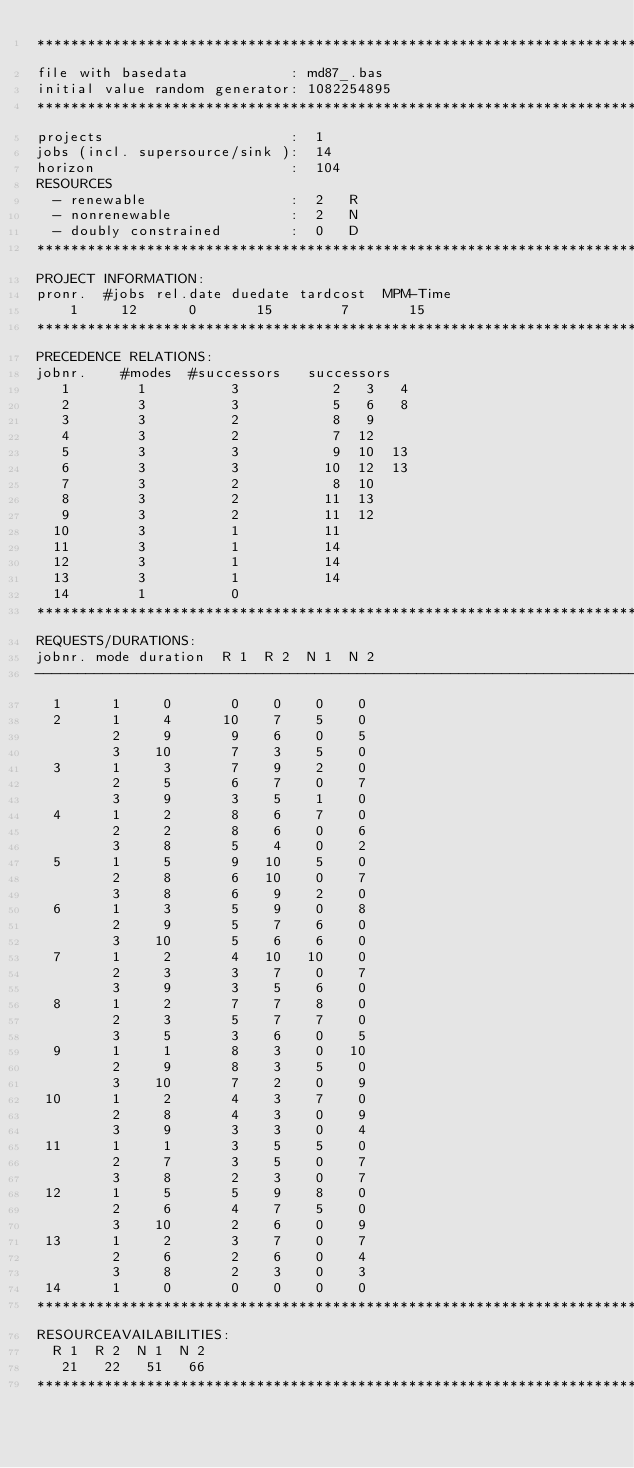Convert code to text. <code><loc_0><loc_0><loc_500><loc_500><_ObjectiveC_>************************************************************************
file with basedata            : md87_.bas
initial value random generator: 1082254895
************************************************************************
projects                      :  1
jobs (incl. supersource/sink ):  14
horizon                       :  104
RESOURCES
  - renewable                 :  2   R
  - nonrenewable              :  2   N
  - doubly constrained        :  0   D
************************************************************************
PROJECT INFORMATION:
pronr.  #jobs rel.date duedate tardcost  MPM-Time
    1     12      0       15        7       15
************************************************************************
PRECEDENCE RELATIONS:
jobnr.    #modes  #successors   successors
   1        1          3           2   3   4
   2        3          3           5   6   8
   3        3          2           8   9
   4        3          2           7  12
   5        3          3           9  10  13
   6        3          3          10  12  13
   7        3          2           8  10
   8        3          2          11  13
   9        3          2          11  12
  10        3          1          11
  11        3          1          14
  12        3          1          14
  13        3          1          14
  14        1          0        
************************************************************************
REQUESTS/DURATIONS:
jobnr. mode duration  R 1  R 2  N 1  N 2
------------------------------------------------------------------------
  1      1     0       0    0    0    0
  2      1     4      10    7    5    0
         2     9       9    6    0    5
         3    10       7    3    5    0
  3      1     3       7    9    2    0
         2     5       6    7    0    7
         3     9       3    5    1    0
  4      1     2       8    6    7    0
         2     2       8    6    0    6
         3     8       5    4    0    2
  5      1     5       9   10    5    0
         2     8       6   10    0    7
         3     8       6    9    2    0
  6      1     3       5    9    0    8
         2     9       5    7    6    0
         3    10       5    6    6    0
  7      1     2       4   10   10    0
         2     3       3    7    0    7
         3     9       3    5    6    0
  8      1     2       7    7    8    0
         2     3       5    7    7    0
         3     5       3    6    0    5
  9      1     1       8    3    0   10
         2     9       8    3    5    0
         3    10       7    2    0    9
 10      1     2       4    3    7    0
         2     8       4    3    0    9
         3     9       3    3    0    4
 11      1     1       3    5    5    0
         2     7       3    5    0    7
         3     8       2    3    0    7
 12      1     5       5    9    8    0
         2     6       4    7    5    0
         3    10       2    6    0    9
 13      1     2       3    7    0    7
         2     6       2    6    0    4
         3     8       2    3    0    3
 14      1     0       0    0    0    0
************************************************************************
RESOURCEAVAILABILITIES:
  R 1  R 2  N 1  N 2
   21   22   51   66
************************************************************************
</code> 